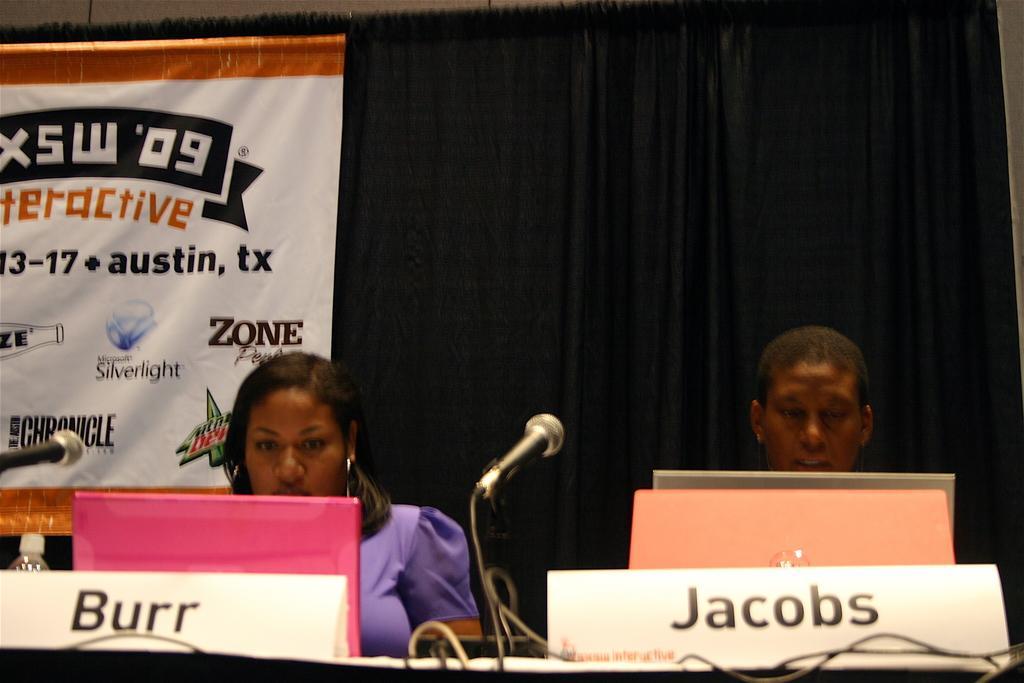How would you summarize this image in a sentence or two? There are two persons sitting. In front of them there is a platform. On that there are name boards, mics with mic stands, laptops, bottle. In the back there is a curtain with banner. 